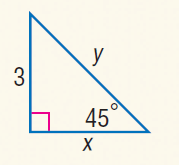Answer the mathemtical geometry problem and directly provide the correct option letter.
Question: Find y.
Choices: A: \sqrt { 2 } B: 2 C: 4 D: 3 \sqrt { 2 } D 